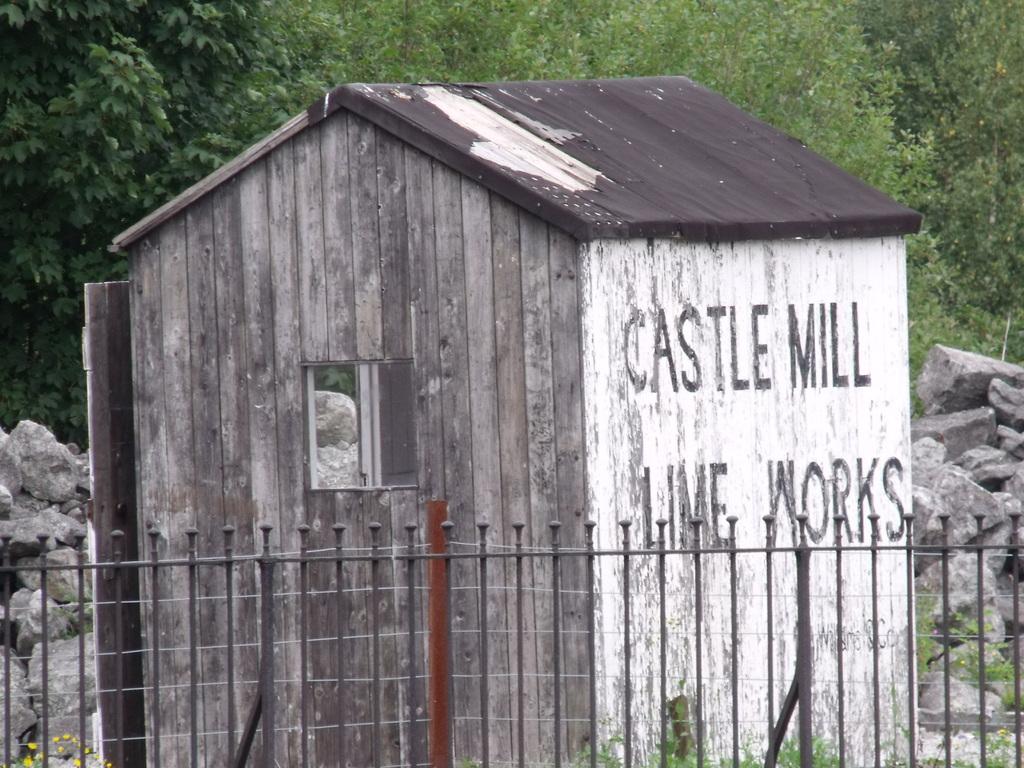Which mill is that for?
Your response must be concise. Castle. What kind of chemical is used?
Offer a very short reply. Lime. 